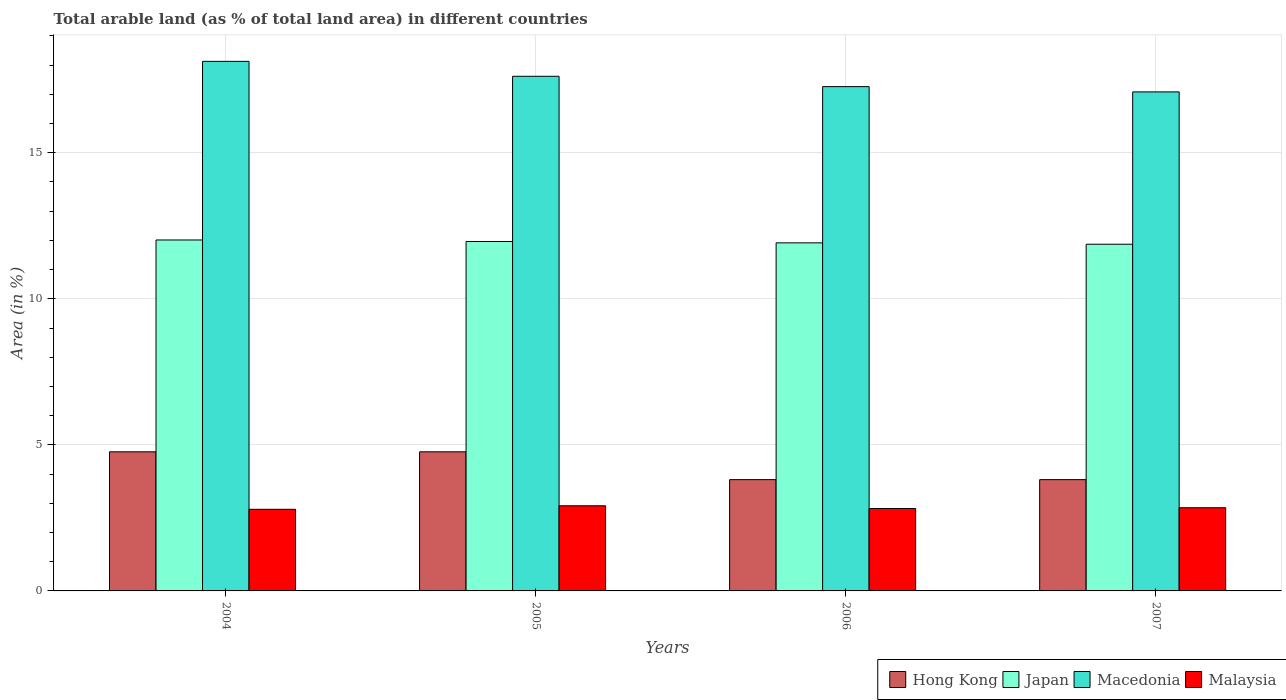How many different coloured bars are there?
Make the answer very short. 4. Are the number of bars per tick equal to the number of legend labels?
Your answer should be very brief. Yes. Are the number of bars on each tick of the X-axis equal?
Ensure brevity in your answer.  Yes. How many bars are there on the 4th tick from the left?
Ensure brevity in your answer.  4. How many bars are there on the 4th tick from the right?
Keep it short and to the point. 4. What is the label of the 4th group of bars from the left?
Your answer should be very brief. 2007. In how many cases, is the number of bars for a given year not equal to the number of legend labels?
Offer a terse response. 0. What is the percentage of arable land in Hong Kong in 2005?
Your answer should be compact. 4.76. Across all years, what is the maximum percentage of arable land in Malaysia?
Provide a short and direct response. 2.91. Across all years, what is the minimum percentage of arable land in Malaysia?
Keep it short and to the point. 2.79. What is the total percentage of arable land in Hong Kong in the graph?
Provide a short and direct response. 17.14. What is the difference between the percentage of arable land in Hong Kong in 2004 and that in 2006?
Give a very brief answer. 0.95. What is the difference between the percentage of arable land in Hong Kong in 2007 and the percentage of arable land in Malaysia in 2005?
Give a very brief answer. 0.89. What is the average percentage of arable land in Macedonia per year?
Offer a terse response. 17.52. In the year 2005, what is the difference between the percentage of arable land in Malaysia and percentage of arable land in Hong Kong?
Offer a terse response. -1.85. In how many years, is the percentage of arable land in Macedonia greater than 12 %?
Ensure brevity in your answer.  4. What is the ratio of the percentage of arable land in Macedonia in 2006 to that in 2007?
Your response must be concise. 1.01. Is the percentage of arable land in Malaysia in 2004 less than that in 2005?
Ensure brevity in your answer.  Yes. What is the difference between the highest and the second highest percentage of arable land in Malaysia?
Offer a terse response. 0.07. What is the difference between the highest and the lowest percentage of arable land in Japan?
Your response must be concise. 0.15. In how many years, is the percentage of arable land in Japan greater than the average percentage of arable land in Japan taken over all years?
Make the answer very short. 2. Is the sum of the percentage of arable land in Macedonia in 2006 and 2007 greater than the maximum percentage of arable land in Hong Kong across all years?
Ensure brevity in your answer.  Yes. Is it the case that in every year, the sum of the percentage of arable land in Hong Kong and percentage of arable land in Malaysia is greater than the sum of percentage of arable land in Macedonia and percentage of arable land in Japan?
Offer a terse response. No. What does the 4th bar from the left in 2007 represents?
Ensure brevity in your answer.  Malaysia. What does the 4th bar from the right in 2007 represents?
Offer a terse response. Hong Kong. Is it the case that in every year, the sum of the percentage of arable land in Hong Kong and percentage of arable land in Malaysia is greater than the percentage of arable land in Macedonia?
Provide a succinct answer. No. How many bars are there?
Make the answer very short. 16. What is the difference between two consecutive major ticks on the Y-axis?
Offer a very short reply. 5. Are the values on the major ticks of Y-axis written in scientific E-notation?
Give a very brief answer. No. Does the graph contain any zero values?
Ensure brevity in your answer.  No. Does the graph contain grids?
Give a very brief answer. Yes. What is the title of the graph?
Make the answer very short. Total arable land (as % of total land area) in different countries. What is the label or title of the Y-axis?
Offer a terse response. Area (in %). What is the Area (in %) of Hong Kong in 2004?
Your answer should be compact. 4.76. What is the Area (in %) of Japan in 2004?
Your response must be concise. 12.01. What is the Area (in %) of Macedonia in 2004?
Offer a terse response. 18.13. What is the Area (in %) in Malaysia in 2004?
Provide a succinct answer. 2.79. What is the Area (in %) of Hong Kong in 2005?
Offer a very short reply. 4.76. What is the Area (in %) in Japan in 2005?
Make the answer very short. 11.96. What is the Area (in %) of Macedonia in 2005?
Provide a succinct answer. 17.62. What is the Area (in %) of Malaysia in 2005?
Ensure brevity in your answer.  2.91. What is the Area (in %) of Hong Kong in 2006?
Give a very brief answer. 3.81. What is the Area (in %) of Japan in 2006?
Your response must be concise. 11.91. What is the Area (in %) in Macedonia in 2006?
Offer a terse response. 17.26. What is the Area (in %) of Malaysia in 2006?
Ensure brevity in your answer.  2.82. What is the Area (in %) of Hong Kong in 2007?
Provide a succinct answer. 3.81. What is the Area (in %) of Japan in 2007?
Give a very brief answer. 11.87. What is the Area (in %) of Macedonia in 2007?
Your answer should be compact. 17.08. What is the Area (in %) of Malaysia in 2007?
Provide a short and direct response. 2.85. Across all years, what is the maximum Area (in %) in Hong Kong?
Give a very brief answer. 4.76. Across all years, what is the maximum Area (in %) in Japan?
Ensure brevity in your answer.  12.01. Across all years, what is the maximum Area (in %) of Macedonia?
Keep it short and to the point. 18.13. Across all years, what is the maximum Area (in %) of Malaysia?
Give a very brief answer. 2.91. Across all years, what is the minimum Area (in %) in Hong Kong?
Make the answer very short. 3.81. Across all years, what is the minimum Area (in %) in Japan?
Keep it short and to the point. 11.87. Across all years, what is the minimum Area (in %) in Macedonia?
Keep it short and to the point. 17.08. Across all years, what is the minimum Area (in %) in Malaysia?
Keep it short and to the point. 2.79. What is the total Area (in %) in Hong Kong in the graph?
Offer a terse response. 17.14. What is the total Area (in %) in Japan in the graph?
Your answer should be compact. 47.76. What is the total Area (in %) in Macedonia in the graph?
Your answer should be very brief. 70.09. What is the total Area (in %) in Malaysia in the graph?
Provide a short and direct response. 11.38. What is the difference between the Area (in %) in Japan in 2004 and that in 2005?
Keep it short and to the point. 0.05. What is the difference between the Area (in %) in Macedonia in 2004 and that in 2005?
Give a very brief answer. 0.51. What is the difference between the Area (in %) of Malaysia in 2004 and that in 2005?
Offer a terse response. -0.12. What is the difference between the Area (in %) in Hong Kong in 2004 and that in 2006?
Make the answer very short. 0.95. What is the difference between the Area (in %) of Japan in 2004 and that in 2006?
Offer a terse response. 0.1. What is the difference between the Area (in %) of Macedonia in 2004 and that in 2006?
Provide a short and direct response. 0.87. What is the difference between the Area (in %) in Malaysia in 2004 and that in 2006?
Your response must be concise. -0.03. What is the difference between the Area (in %) in Hong Kong in 2004 and that in 2007?
Provide a short and direct response. 0.95. What is the difference between the Area (in %) in Japan in 2004 and that in 2007?
Make the answer very short. 0.15. What is the difference between the Area (in %) in Macedonia in 2004 and that in 2007?
Ensure brevity in your answer.  1.05. What is the difference between the Area (in %) of Malaysia in 2004 and that in 2007?
Provide a succinct answer. -0.05. What is the difference between the Area (in %) of Hong Kong in 2005 and that in 2006?
Offer a very short reply. 0.95. What is the difference between the Area (in %) in Japan in 2005 and that in 2006?
Ensure brevity in your answer.  0.05. What is the difference between the Area (in %) in Macedonia in 2005 and that in 2006?
Provide a succinct answer. 0.35. What is the difference between the Area (in %) of Malaysia in 2005 and that in 2006?
Give a very brief answer. 0.09. What is the difference between the Area (in %) of Japan in 2005 and that in 2007?
Make the answer very short. 0.09. What is the difference between the Area (in %) of Macedonia in 2005 and that in 2007?
Offer a terse response. 0.53. What is the difference between the Area (in %) of Malaysia in 2005 and that in 2007?
Your answer should be very brief. 0.07. What is the difference between the Area (in %) of Hong Kong in 2006 and that in 2007?
Provide a succinct answer. 0. What is the difference between the Area (in %) in Japan in 2006 and that in 2007?
Provide a short and direct response. 0.05. What is the difference between the Area (in %) of Macedonia in 2006 and that in 2007?
Keep it short and to the point. 0.18. What is the difference between the Area (in %) in Malaysia in 2006 and that in 2007?
Offer a terse response. -0.03. What is the difference between the Area (in %) of Hong Kong in 2004 and the Area (in %) of Japan in 2005?
Keep it short and to the point. -7.2. What is the difference between the Area (in %) in Hong Kong in 2004 and the Area (in %) in Macedonia in 2005?
Provide a short and direct response. -12.86. What is the difference between the Area (in %) of Hong Kong in 2004 and the Area (in %) of Malaysia in 2005?
Your answer should be compact. 1.85. What is the difference between the Area (in %) of Japan in 2004 and the Area (in %) of Macedonia in 2005?
Your response must be concise. -5.6. What is the difference between the Area (in %) of Japan in 2004 and the Area (in %) of Malaysia in 2005?
Your answer should be very brief. 9.1. What is the difference between the Area (in %) of Macedonia in 2004 and the Area (in %) of Malaysia in 2005?
Offer a very short reply. 15.21. What is the difference between the Area (in %) in Hong Kong in 2004 and the Area (in %) in Japan in 2006?
Your response must be concise. -7.15. What is the difference between the Area (in %) in Hong Kong in 2004 and the Area (in %) in Macedonia in 2006?
Your answer should be compact. -12.5. What is the difference between the Area (in %) in Hong Kong in 2004 and the Area (in %) in Malaysia in 2006?
Your answer should be very brief. 1.94. What is the difference between the Area (in %) in Japan in 2004 and the Area (in %) in Macedonia in 2006?
Ensure brevity in your answer.  -5.25. What is the difference between the Area (in %) of Japan in 2004 and the Area (in %) of Malaysia in 2006?
Your answer should be compact. 9.19. What is the difference between the Area (in %) of Macedonia in 2004 and the Area (in %) of Malaysia in 2006?
Keep it short and to the point. 15.31. What is the difference between the Area (in %) of Hong Kong in 2004 and the Area (in %) of Japan in 2007?
Offer a terse response. -7.11. What is the difference between the Area (in %) of Hong Kong in 2004 and the Area (in %) of Macedonia in 2007?
Your answer should be compact. -12.32. What is the difference between the Area (in %) of Hong Kong in 2004 and the Area (in %) of Malaysia in 2007?
Your answer should be very brief. 1.91. What is the difference between the Area (in %) in Japan in 2004 and the Area (in %) in Macedonia in 2007?
Provide a short and direct response. -5.07. What is the difference between the Area (in %) of Japan in 2004 and the Area (in %) of Malaysia in 2007?
Give a very brief answer. 9.17. What is the difference between the Area (in %) in Macedonia in 2004 and the Area (in %) in Malaysia in 2007?
Your answer should be compact. 15.28. What is the difference between the Area (in %) in Hong Kong in 2005 and the Area (in %) in Japan in 2006?
Provide a short and direct response. -7.15. What is the difference between the Area (in %) in Hong Kong in 2005 and the Area (in %) in Macedonia in 2006?
Ensure brevity in your answer.  -12.5. What is the difference between the Area (in %) in Hong Kong in 2005 and the Area (in %) in Malaysia in 2006?
Make the answer very short. 1.94. What is the difference between the Area (in %) of Japan in 2005 and the Area (in %) of Macedonia in 2006?
Offer a terse response. -5.3. What is the difference between the Area (in %) of Japan in 2005 and the Area (in %) of Malaysia in 2006?
Keep it short and to the point. 9.14. What is the difference between the Area (in %) in Macedonia in 2005 and the Area (in %) in Malaysia in 2006?
Your response must be concise. 14.8. What is the difference between the Area (in %) of Hong Kong in 2005 and the Area (in %) of Japan in 2007?
Provide a succinct answer. -7.11. What is the difference between the Area (in %) of Hong Kong in 2005 and the Area (in %) of Macedonia in 2007?
Provide a succinct answer. -12.32. What is the difference between the Area (in %) of Hong Kong in 2005 and the Area (in %) of Malaysia in 2007?
Offer a very short reply. 1.91. What is the difference between the Area (in %) in Japan in 2005 and the Area (in %) in Macedonia in 2007?
Provide a short and direct response. -5.12. What is the difference between the Area (in %) in Japan in 2005 and the Area (in %) in Malaysia in 2007?
Provide a succinct answer. 9.11. What is the difference between the Area (in %) in Macedonia in 2005 and the Area (in %) in Malaysia in 2007?
Make the answer very short. 14.77. What is the difference between the Area (in %) in Hong Kong in 2006 and the Area (in %) in Japan in 2007?
Make the answer very short. -8.06. What is the difference between the Area (in %) of Hong Kong in 2006 and the Area (in %) of Macedonia in 2007?
Your answer should be very brief. -13.27. What is the difference between the Area (in %) of Hong Kong in 2006 and the Area (in %) of Malaysia in 2007?
Give a very brief answer. 0.96. What is the difference between the Area (in %) in Japan in 2006 and the Area (in %) in Macedonia in 2007?
Provide a succinct answer. -5.17. What is the difference between the Area (in %) of Japan in 2006 and the Area (in %) of Malaysia in 2007?
Your answer should be very brief. 9.07. What is the difference between the Area (in %) in Macedonia in 2006 and the Area (in %) in Malaysia in 2007?
Offer a terse response. 14.42. What is the average Area (in %) in Hong Kong per year?
Offer a very short reply. 4.29. What is the average Area (in %) of Japan per year?
Your answer should be compact. 11.94. What is the average Area (in %) of Macedonia per year?
Keep it short and to the point. 17.52. What is the average Area (in %) of Malaysia per year?
Make the answer very short. 2.84. In the year 2004, what is the difference between the Area (in %) of Hong Kong and Area (in %) of Japan?
Provide a short and direct response. -7.25. In the year 2004, what is the difference between the Area (in %) of Hong Kong and Area (in %) of Macedonia?
Offer a terse response. -13.37. In the year 2004, what is the difference between the Area (in %) of Hong Kong and Area (in %) of Malaysia?
Make the answer very short. 1.97. In the year 2004, what is the difference between the Area (in %) of Japan and Area (in %) of Macedonia?
Keep it short and to the point. -6.11. In the year 2004, what is the difference between the Area (in %) in Japan and Area (in %) in Malaysia?
Provide a short and direct response. 9.22. In the year 2004, what is the difference between the Area (in %) of Macedonia and Area (in %) of Malaysia?
Keep it short and to the point. 15.33. In the year 2005, what is the difference between the Area (in %) in Hong Kong and Area (in %) in Japan?
Provide a succinct answer. -7.2. In the year 2005, what is the difference between the Area (in %) of Hong Kong and Area (in %) of Macedonia?
Give a very brief answer. -12.86. In the year 2005, what is the difference between the Area (in %) in Hong Kong and Area (in %) in Malaysia?
Give a very brief answer. 1.85. In the year 2005, what is the difference between the Area (in %) in Japan and Area (in %) in Macedonia?
Your response must be concise. -5.66. In the year 2005, what is the difference between the Area (in %) in Japan and Area (in %) in Malaysia?
Offer a very short reply. 9.05. In the year 2005, what is the difference between the Area (in %) of Macedonia and Area (in %) of Malaysia?
Ensure brevity in your answer.  14.7. In the year 2006, what is the difference between the Area (in %) in Hong Kong and Area (in %) in Japan?
Offer a very short reply. -8.11. In the year 2006, what is the difference between the Area (in %) of Hong Kong and Area (in %) of Macedonia?
Provide a short and direct response. -13.45. In the year 2006, what is the difference between the Area (in %) of Hong Kong and Area (in %) of Malaysia?
Ensure brevity in your answer.  0.99. In the year 2006, what is the difference between the Area (in %) of Japan and Area (in %) of Macedonia?
Ensure brevity in your answer.  -5.35. In the year 2006, what is the difference between the Area (in %) in Japan and Area (in %) in Malaysia?
Provide a short and direct response. 9.09. In the year 2006, what is the difference between the Area (in %) of Macedonia and Area (in %) of Malaysia?
Your answer should be very brief. 14.44. In the year 2007, what is the difference between the Area (in %) in Hong Kong and Area (in %) in Japan?
Offer a very short reply. -8.06. In the year 2007, what is the difference between the Area (in %) of Hong Kong and Area (in %) of Macedonia?
Provide a succinct answer. -13.27. In the year 2007, what is the difference between the Area (in %) of Hong Kong and Area (in %) of Malaysia?
Make the answer very short. 0.96. In the year 2007, what is the difference between the Area (in %) of Japan and Area (in %) of Macedonia?
Give a very brief answer. -5.21. In the year 2007, what is the difference between the Area (in %) in Japan and Area (in %) in Malaysia?
Your answer should be very brief. 9.02. In the year 2007, what is the difference between the Area (in %) of Macedonia and Area (in %) of Malaysia?
Make the answer very short. 14.24. What is the ratio of the Area (in %) of Macedonia in 2004 to that in 2005?
Your response must be concise. 1.03. What is the ratio of the Area (in %) in Malaysia in 2004 to that in 2005?
Your answer should be compact. 0.96. What is the ratio of the Area (in %) of Japan in 2004 to that in 2006?
Keep it short and to the point. 1.01. What is the ratio of the Area (in %) of Macedonia in 2004 to that in 2006?
Offer a terse response. 1.05. What is the ratio of the Area (in %) in Malaysia in 2004 to that in 2006?
Ensure brevity in your answer.  0.99. What is the ratio of the Area (in %) in Hong Kong in 2004 to that in 2007?
Your answer should be compact. 1.25. What is the ratio of the Area (in %) in Japan in 2004 to that in 2007?
Your answer should be compact. 1.01. What is the ratio of the Area (in %) of Macedonia in 2004 to that in 2007?
Your answer should be very brief. 1.06. What is the ratio of the Area (in %) of Malaysia in 2004 to that in 2007?
Ensure brevity in your answer.  0.98. What is the ratio of the Area (in %) in Japan in 2005 to that in 2006?
Offer a terse response. 1. What is the ratio of the Area (in %) of Macedonia in 2005 to that in 2006?
Offer a terse response. 1.02. What is the ratio of the Area (in %) of Malaysia in 2005 to that in 2006?
Your answer should be very brief. 1.03. What is the ratio of the Area (in %) in Hong Kong in 2005 to that in 2007?
Keep it short and to the point. 1.25. What is the ratio of the Area (in %) in Japan in 2005 to that in 2007?
Offer a terse response. 1.01. What is the ratio of the Area (in %) in Macedonia in 2005 to that in 2007?
Your answer should be compact. 1.03. What is the ratio of the Area (in %) of Malaysia in 2005 to that in 2007?
Offer a terse response. 1.02. What is the ratio of the Area (in %) in Hong Kong in 2006 to that in 2007?
Your response must be concise. 1. What is the ratio of the Area (in %) of Macedonia in 2006 to that in 2007?
Give a very brief answer. 1.01. What is the ratio of the Area (in %) in Malaysia in 2006 to that in 2007?
Ensure brevity in your answer.  0.99. What is the difference between the highest and the second highest Area (in %) in Hong Kong?
Keep it short and to the point. 0. What is the difference between the highest and the second highest Area (in %) in Japan?
Ensure brevity in your answer.  0.05. What is the difference between the highest and the second highest Area (in %) of Macedonia?
Your answer should be very brief. 0.51. What is the difference between the highest and the second highest Area (in %) in Malaysia?
Your answer should be compact. 0.07. What is the difference between the highest and the lowest Area (in %) in Hong Kong?
Offer a very short reply. 0.95. What is the difference between the highest and the lowest Area (in %) in Japan?
Keep it short and to the point. 0.15. What is the difference between the highest and the lowest Area (in %) of Macedonia?
Your answer should be very brief. 1.05. What is the difference between the highest and the lowest Area (in %) of Malaysia?
Give a very brief answer. 0.12. 